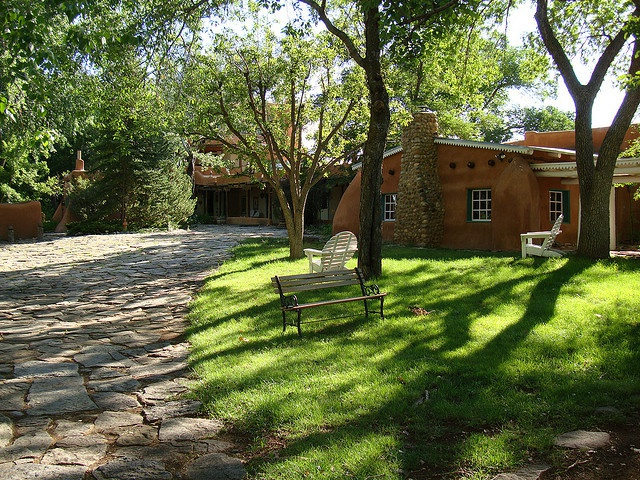Describe the objects in this image and their specific colors. I can see bench in black, darkgreen, and gray tones, chair in black, olive, gray, white, and darkgray tones, and chair in black, gray, olive, and darkgreen tones in this image. 